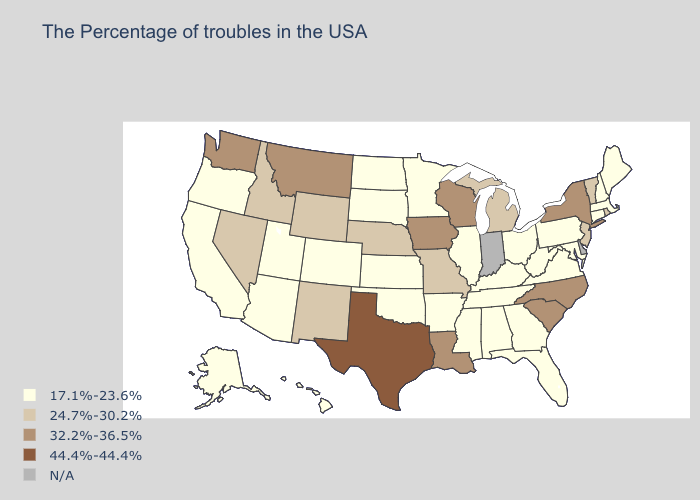Does Oklahoma have the highest value in the USA?
Answer briefly. No. Which states have the highest value in the USA?
Quick response, please. Texas. What is the lowest value in the South?
Quick response, please. 17.1%-23.6%. Which states have the highest value in the USA?
Write a very short answer. Texas. What is the highest value in the West ?
Keep it brief. 32.2%-36.5%. Among the states that border Utah , does Arizona have the lowest value?
Quick response, please. Yes. What is the highest value in the USA?
Keep it brief. 44.4%-44.4%. What is the value of Oklahoma?
Be succinct. 17.1%-23.6%. Among the states that border Montana , which have the lowest value?
Short answer required. South Dakota, North Dakota. Which states have the lowest value in the MidWest?
Answer briefly. Ohio, Illinois, Minnesota, Kansas, South Dakota, North Dakota. What is the lowest value in the West?
Write a very short answer. 17.1%-23.6%. Among the states that border Indiana , which have the highest value?
Keep it brief. Michigan. What is the lowest value in states that border South Dakota?
Give a very brief answer. 17.1%-23.6%. 